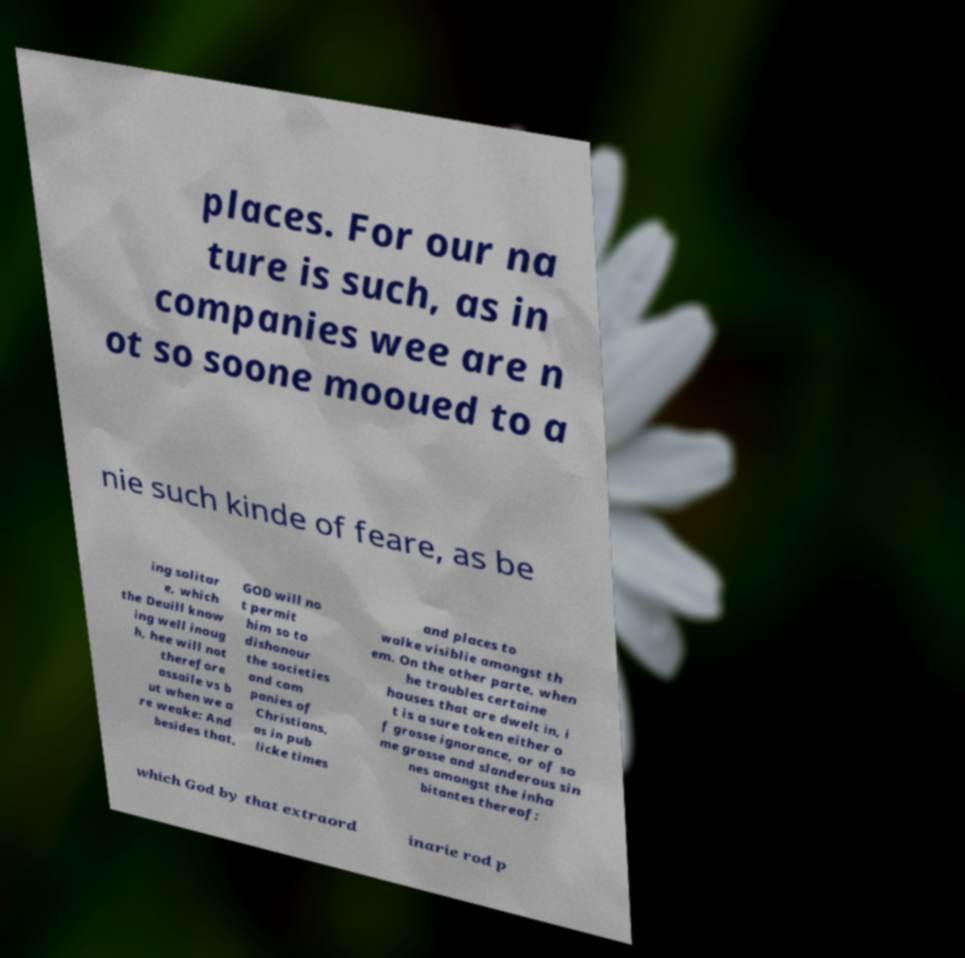I need the written content from this picture converted into text. Can you do that? places. For our na ture is such, as in companies wee are n ot so soone mooued to a nie such kinde of feare, as be ing solitar e, which the Deuill know ing well inoug h, hee will not therefore assaile vs b ut when we a re weake: And besides that, GOD will no t permit him so to dishonour the societies and com panies of Christians, as in pub licke times and places to walke visiblie amongst th em. On the other parte, when he troubles certaine houses that are dwelt in, i t is a sure token either o f grosse ignorance, or of so me grosse and slanderous sin nes amongst the inha bitantes thereof: which God by that extraord inarie rod p 